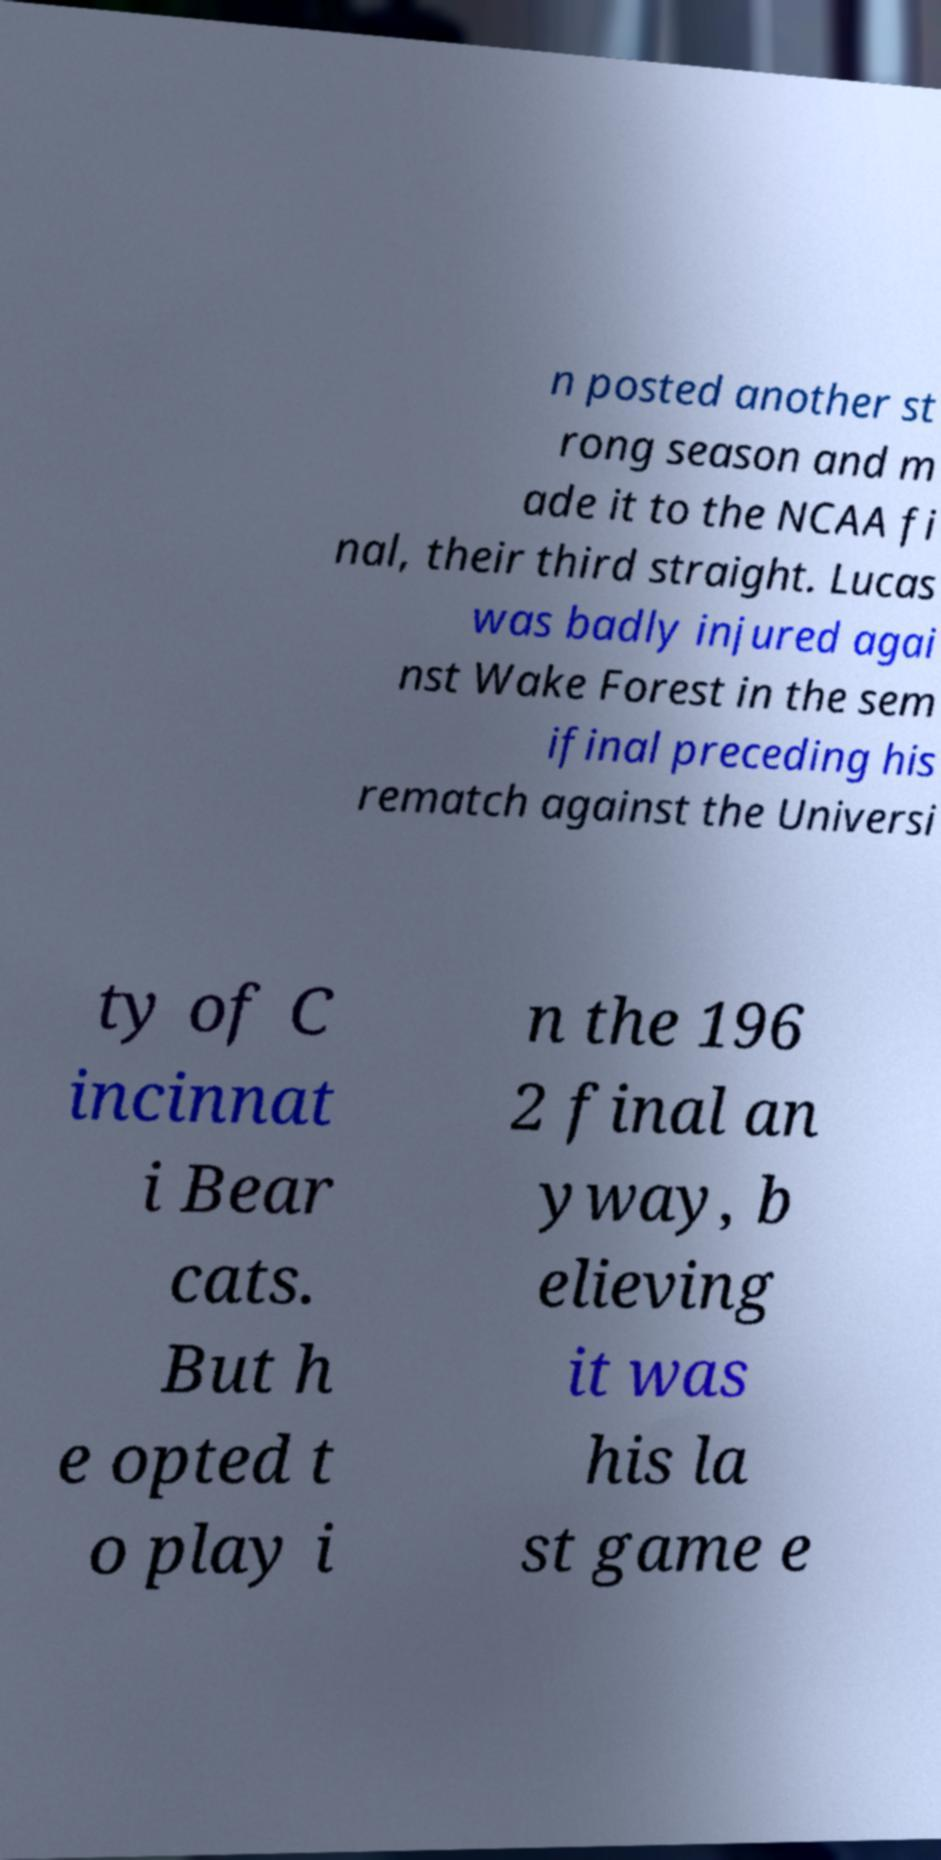Can you read and provide the text displayed in the image?This photo seems to have some interesting text. Can you extract and type it out for me? n posted another st rong season and m ade it to the NCAA fi nal, their third straight. Lucas was badly injured agai nst Wake Forest in the sem ifinal preceding his rematch against the Universi ty of C incinnat i Bear cats. But h e opted t o play i n the 196 2 final an yway, b elieving it was his la st game e 